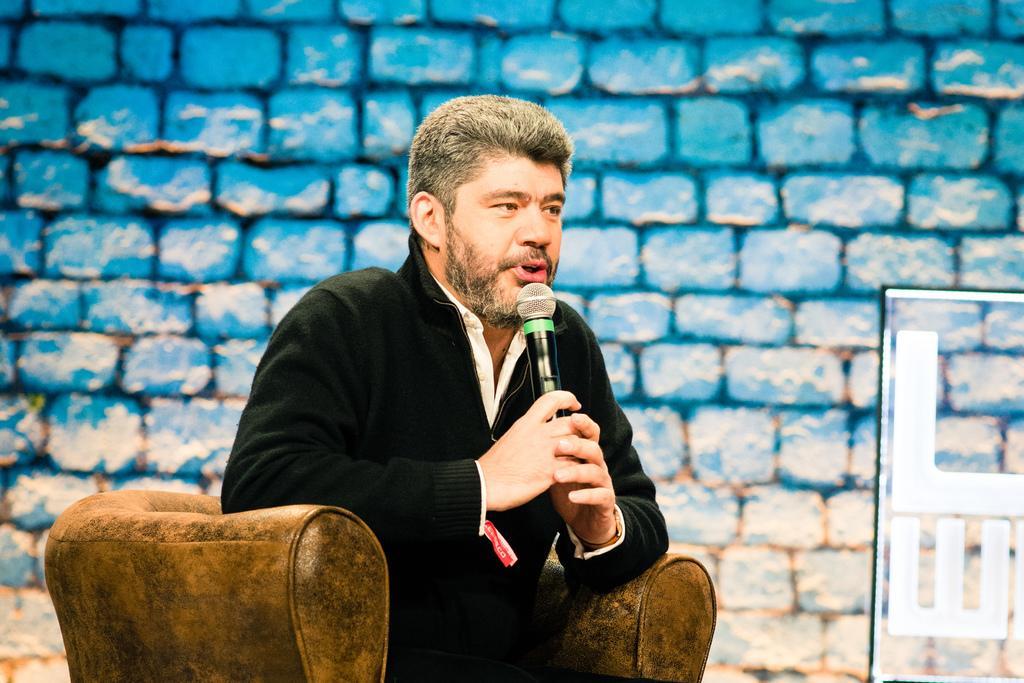How would you summarize this image in a sentence or two? In this image we can see a person sitting on a sofa chair. He is holding a mic. In the back there is a brick wall. There is a glass wall with letters on the right side. 